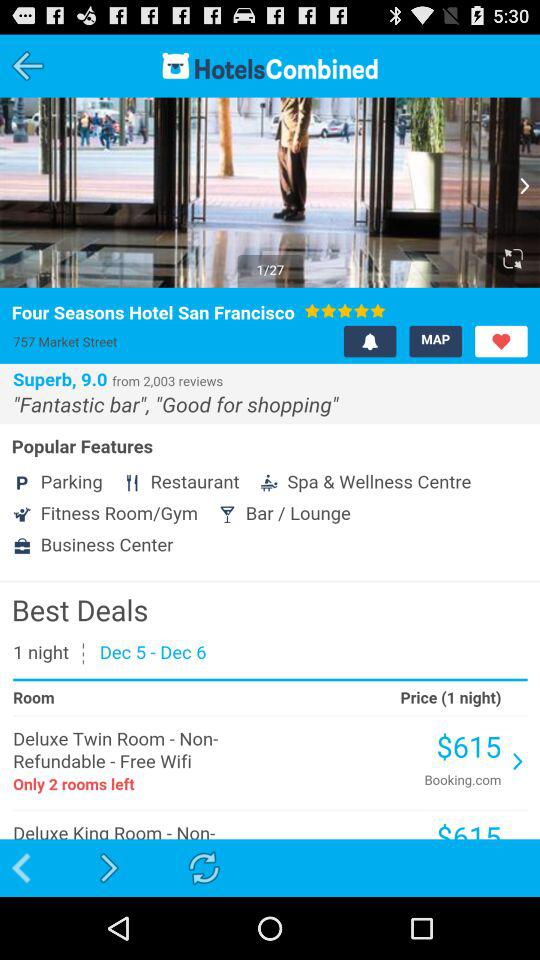What is the name of the hotel? The name of the hotel is "Hotel San Francisco". 